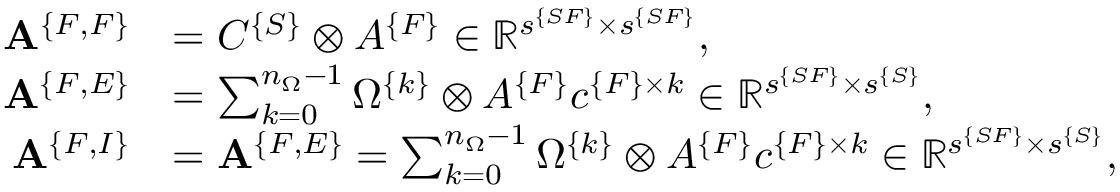Convert formula to latex. <formula><loc_0><loc_0><loc_500><loc_500>\begin{array} { r l } { { A } ^ { \{ F , F \} } } & { = C ^ { \{ S \} } \otimes A ^ { \{ F \} } \in \mathbb { R } ^ { s ^ { \{ S F \} } \times s ^ { \{ S F \} } } , } \\ { { A } ^ { \{ F , E \} } } & { = \sum _ { k = 0 } ^ { n _ { \Omega } - 1 } \Omega ^ { \{ k \} } \otimes A ^ { \{ F \} } c ^ { \{ F \} \times k } \in \mathbb { R } ^ { s ^ { \{ S F \} } \times s ^ { \{ S \} } } , } \\ { { A } ^ { \{ F , I \} } } & { = { A } ^ { \{ F , E \} } = \sum _ { k = 0 } ^ { n _ { \Omega } - 1 } \Omega ^ { \{ k \} } \otimes A ^ { \{ F \} } c ^ { \{ F \} \times k } \in \mathbb { R } ^ { s ^ { \{ S F \} } \times s ^ { \{ S \} } } , } \end{array}</formula> 